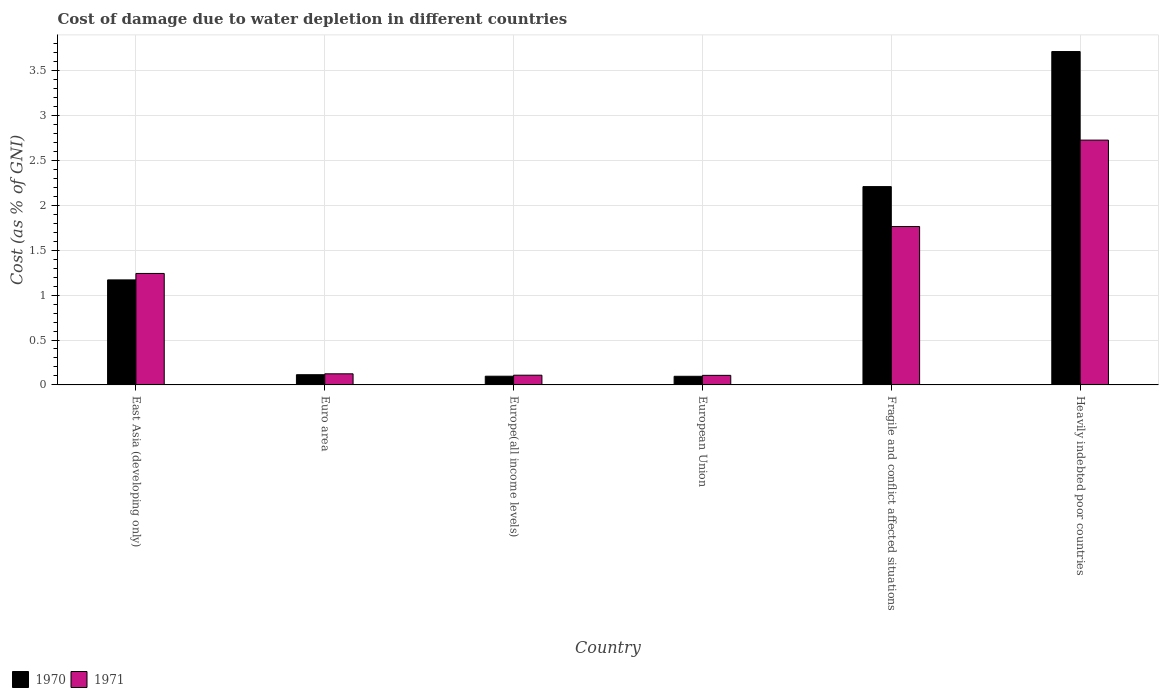Are the number of bars on each tick of the X-axis equal?
Provide a short and direct response. Yes. What is the label of the 3rd group of bars from the left?
Give a very brief answer. Europe(all income levels). What is the cost of damage caused due to water depletion in 1971 in East Asia (developing only)?
Offer a terse response. 1.24. Across all countries, what is the maximum cost of damage caused due to water depletion in 1971?
Offer a very short reply. 2.73. Across all countries, what is the minimum cost of damage caused due to water depletion in 1971?
Your answer should be compact. 0.11. In which country was the cost of damage caused due to water depletion in 1971 maximum?
Offer a terse response. Heavily indebted poor countries. What is the total cost of damage caused due to water depletion in 1970 in the graph?
Ensure brevity in your answer.  7.4. What is the difference between the cost of damage caused due to water depletion in 1970 in East Asia (developing only) and that in Heavily indebted poor countries?
Your answer should be very brief. -2.54. What is the difference between the cost of damage caused due to water depletion in 1970 in Heavily indebted poor countries and the cost of damage caused due to water depletion in 1971 in Euro area?
Offer a very short reply. 3.59. What is the average cost of damage caused due to water depletion in 1970 per country?
Ensure brevity in your answer.  1.23. What is the difference between the cost of damage caused due to water depletion of/in 1970 and cost of damage caused due to water depletion of/in 1971 in Fragile and conflict affected situations?
Make the answer very short. 0.44. In how many countries, is the cost of damage caused due to water depletion in 1971 greater than 1.6 %?
Your answer should be very brief. 2. What is the ratio of the cost of damage caused due to water depletion in 1970 in East Asia (developing only) to that in Euro area?
Ensure brevity in your answer.  10.3. Is the difference between the cost of damage caused due to water depletion in 1970 in Euro area and Heavily indebted poor countries greater than the difference between the cost of damage caused due to water depletion in 1971 in Euro area and Heavily indebted poor countries?
Offer a very short reply. No. What is the difference between the highest and the second highest cost of damage caused due to water depletion in 1970?
Your answer should be very brief. -1.04. What is the difference between the highest and the lowest cost of damage caused due to water depletion in 1971?
Your response must be concise. 2.62. Is the sum of the cost of damage caused due to water depletion in 1971 in Fragile and conflict affected situations and Heavily indebted poor countries greater than the maximum cost of damage caused due to water depletion in 1970 across all countries?
Offer a very short reply. Yes. What does the 1st bar from the left in Heavily indebted poor countries represents?
Your response must be concise. 1970. What does the 2nd bar from the right in Fragile and conflict affected situations represents?
Your answer should be compact. 1970. How many bars are there?
Make the answer very short. 12. Are all the bars in the graph horizontal?
Offer a very short reply. No. How many countries are there in the graph?
Your response must be concise. 6. Are the values on the major ticks of Y-axis written in scientific E-notation?
Offer a very short reply. No. Does the graph contain grids?
Your answer should be very brief. Yes. How many legend labels are there?
Offer a very short reply. 2. How are the legend labels stacked?
Your response must be concise. Horizontal. What is the title of the graph?
Provide a short and direct response. Cost of damage due to water depletion in different countries. Does "1987" appear as one of the legend labels in the graph?
Offer a terse response. No. What is the label or title of the X-axis?
Your response must be concise. Country. What is the label or title of the Y-axis?
Offer a very short reply. Cost (as % of GNI). What is the Cost (as % of GNI) in 1970 in East Asia (developing only)?
Your answer should be compact. 1.17. What is the Cost (as % of GNI) of 1971 in East Asia (developing only)?
Provide a succinct answer. 1.24. What is the Cost (as % of GNI) in 1970 in Euro area?
Ensure brevity in your answer.  0.11. What is the Cost (as % of GNI) of 1971 in Euro area?
Your answer should be compact. 0.12. What is the Cost (as % of GNI) of 1970 in Europe(all income levels)?
Your response must be concise. 0.1. What is the Cost (as % of GNI) of 1971 in Europe(all income levels)?
Offer a terse response. 0.11. What is the Cost (as % of GNI) in 1970 in European Union?
Keep it short and to the point. 0.1. What is the Cost (as % of GNI) of 1971 in European Union?
Ensure brevity in your answer.  0.11. What is the Cost (as % of GNI) in 1970 in Fragile and conflict affected situations?
Offer a very short reply. 2.21. What is the Cost (as % of GNI) of 1971 in Fragile and conflict affected situations?
Offer a terse response. 1.76. What is the Cost (as % of GNI) of 1970 in Heavily indebted poor countries?
Ensure brevity in your answer.  3.71. What is the Cost (as % of GNI) of 1971 in Heavily indebted poor countries?
Provide a short and direct response. 2.73. Across all countries, what is the maximum Cost (as % of GNI) in 1970?
Offer a terse response. 3.71. Across all countries, what is the maximum Cost (as % of GNI) in 1971?
Your answer should be very brief. 2.73. Across all countries, what is the minimum Cost (as % of GNI) of 1970?
Your response must be concise. 0.1. Across all countries, what is the minimum Cost (as % of GNI) of 1971?
Give a very brief answer. 0.11. What is the total Cost (as % of GNI) in 1970 in the graph?
Offer a terse response. 7.4. What is the total Cost (as % of GNI) in 1971 in the graph?
Your answer should be compact. 6.07. What is the difference between the Cost (as % of GNI) of 1970 in East Asia (developing only) and that in Euro area?
Give a very brief answer. 1.06. What is the difference between the Cost (as % of GNI) in 1971 in East Asia (developing only) and that in Euro area?
Your response must be concise. 1.12. What is the difference between the Cost (as % of GNI) of 1970 in East Asia (developing only) and that in Europe(all income levels)?
Ensure brevity in your answer.  1.07. What is the difference between the Cost (as % of GNI) of 1971 in East Asia (developing only) and that in Europe(all income levels)?
Offer a very short reply. 1.13. What is the difference between the Cost (as % of GNI) of 1970 in East Asia (developing only) and that in European Union?
Give a very brief answer. 1.07. What is the difference between the Cost (as % of GNI) of 1971 in East Asia (developing only) and that in European Union?
Keep it short and to the point. 1.13. What is the difference between the Cost (as % of GNI) of 1970 in East Asia (developing only) and that in Fragile and conflict affected situations?
Provide a short and direct response. -1.04. What is the difference between the Cost (as % of GNI) in 1971 in East Asia (developing only) and that in Fragile and conflict affected situations?
Offer a very short reply. -0.52. What is the difference between the Cost (as % of GNI) of 1970 in East Asia (developing only) and that in Heavily indebted poor countries?
Provide a succinct answer. -2.54. What is the difference between the Cost (as % of GNI) in 1971 in East Asia (developing only) and that in Heavily indebted poor countries?
Give a very brief answer. -1.48. What is the difference between the Cost (as % of GNI) of 1970 in Euro area and that in Europe(all income levels)?
Keep it short and to the point. 0.02. What is the difference between the Cost (as % of GNI) in 1971 in Euro area and that in Europe(all income levels)?
Provide a succinct answer. 0.02. What is the difference between the Cost (as % of GNI) in 1970 in Euro area and that in European Union?
Provide a short and direct response. 0.02. What is the difference between the Cost (as % of GNI) in 1971 in Euro area and that in European Union?
Ensure brevity in your answer.  0.02. What is the difference between the Cost (as % of GNI) in 1970 in Euro area and that in Fragile and conflict affected situations?
Ensure brevity in your answer.  -2.09. What is the difference between the Cost (as % of GNI) of 1971 in Euro area and that in Fragile and conflict affected situations?
Offer a terse response. -1.64. What is the difference between the Cost (as % of GNI) in 1970 in Euro area and that in Heavily indebted poor countries?
Keep it short and to the point. -3.6. What is the difference between the Cost (as % of GNI) in 1971 in Euro area and that in Heavily indebted poor countries?
Your answer should be compact. -2.6. What is the difference between the Cost (as % of GNI) of 1970 in Europe(all income levels) and that in European Union?
Ensure brevity in your answer.  0. What is the difference between the Cost (as % of GNI) in 1971 in Europe(all income levels) and that in European Union?
Provide a short and direct response. 0. What is the difference between the Cost (as % of GNI) in 1970 in Europe(all income levels) and that in Fragile and conflict affected situations?
Offer a terse response. -2.11. What is the difference between the Cost (as % of GNI) of 1971 in Europe(all income levels) and that in Fragile and conflict affected situations?
Offer a terse response. -1.66. What is the difference between the Cost (as % of GNI) in 1970 in Europe(all income levels) and that in Heavily indebted poor countries?
Ensure brevity in your answer.  -3.62. What is the difference between the Cost (as % of GNI) in 1971 in Europe(all income levels) and that in Heavily indebted poor countries?
Ensure brevity in your answer.  -2.62. What is the difference between the Cost (as % of GNI) in 1970 in European Union and that in Fragile and conflict affected situations?
Your response must be concise. -2.11. What is the difference between the Cost (as % of GNI) in 1971 in European Union and that in Fragile and conflict affected situations?
Provide a succinct answer. -1.66. What is the difference between the Cost (as % of GNI) of 1970 in European Union and that in Heavily indebted poor countries?
Offer a very short reply. -3.62. What is the difference between the Cost (as % of GNI) in 1971 in European Union and that in Heavily indebted poor countries?
Your answer should be compact. -2.62. What is the difference between the Cost (as % of GNI) in 1970 in Fragile and conflict affected situations and that in Heavily indebted poor countries?
Your response must be concise. -1.5. What is the difference between the Cost (as % of GNI) of 1971 in Fragile and conflict affected situations and that in Heavily indebted poor countries?
Your answer should be very brief. -0.96. What is the difference between the Cost (as % of GNI) of 1970 in East Asia (developing only) and the Cost (as % of GNI) of 1971 in Euro area?
Your answer should be very brief. 1.05. What is the difference between the Cost (as % of GNI) in 1970 in East Asia (developing only) and the Cost (as % of GNI) in 1971 in Europe(all income levels)?
Offer a terse response. 1.06. What is the difference between the Cost (as % of GNI) of 1970 in East Asia (developing only) and the Cost (as % of GNI) of 1971 in European Union?
Provide a short and direct response. 1.06. What is the difference between the Cost (as % of GNI) of 1970 in East Asia (developing only) and the Cost (as % of GNI) of 1971 in Fragile and conflict affected situations?
Ensure brevity in your answer.  -0.59. What is the difference between the Cost (as % of GNI) of 1970 in East Asia (developing only) and the Cost (as % of GNI) of 1971 in Heavily indebted poor countries?
Your answer should be very brief. -1.56. What is the difference between the Cost (as % of GNI) of 1970 in Euro area and the Cost (as % of GNI) of 1971 in Europe(all income levels)?
Provide a succinct answer. 0.01. What is the difference between the Cost (as % of GNI) of 1970 in Euro area and the Cost (as % of GNI) of 1971 in European Union?
Provide a succinct answer. 0.01. What is the difference between the Cost (as % of GNI) of 1970 in Euro area and the Cost (as % of GNI) of 1971 in Fragile and conflict affected situations?
Your response must be concise. -1.65. What is the difference between the Cost (as % of GNI) in 1970 in Euro area and the Cost (as % of GNI) in 1971 in Heavily indebted poor countries?
Provide a short and direct response. -2.61. What is the difference between the Cost (as % of GNI) of 1970 in Europe(all income levels) and the Cost (as % of GNI) of 1971 in European Union?
Offer a terse response. -0.01. What is the difference between the Cost (as % of GNI) in 1970 in Europe(all income levels) and the Cost (as % of GNI) in 1971 in Fragile and conflict affected situations?
Keep it short and to the point. -1.67. What is the difference between the Cost (as % of GNI) in 1970 in Europe(all income levels) and the Cost (as % of GNI) in 1971 in Heavily indebted poor countries?
Provide a short and direct response. -2.63. What is the difference between the Cost (as % of GNI) of 1970 in European Union and the Cost (as % of GNI) of 1971 in Fragile and conflict affected situations?
Your response must be concise. -1.67. What is the difference between the Cost (as % of GNI) in 1970 in European Union and the Cost (as % of GNI) in 1971 in Heavily indebted poor countries?
Ensure brevity in your answer.  -2.63. What is the difference between the Cost (as % of GNI) of 1970 in Fragile and conflict affected situations and the Cost (as % of GNI) of 1971 in Heavily indebted poor countries?
Offer a very short reply. -0.52. What is the average Cost (as % of GNI) in 1970 per country?
Offer a very short reply. 1.23. What is the average Cost (as % of GNI) of 1971 per country?
Give a very brief answer. 1.01. What is the difference between the Cost (as % of GNI) in 1970 and Cost (as % of GNI) in 1971 in East Asia (developing only)?
Provide a succinct answer. -0.07. What is the difference between the Cost (as % of GNI) of 1970 and Cost (as % of GNI) of 1971 in Euro area?
Provide a short and direct response. -0.01. What is the difference between the Cost (as % of GNI) of 1970 and Cost (as % of GNI) of 1971 in Europe(all income levels)?
Offer a terse response. -0.01. What is the difference between the Cost (as % of GNI) in 1970 and Cost (as % of GNI) in 1971 in European Union?
Offer a terse response. -0.01. What is the difference between the Cost (as % of GNI) in 1970 and Cost (as % of GNI) in 1971 in Fragile and conflict affected situations?
Provide a succinct answer. 0.44. What is the difference between the Cost (as % of GNI) in 1970 and Cost (as % of GNI) in 1971 in Heavily indebted poor countries?
Your answer should be compact. 0.99. What is the ratio of the Cost (as % of GNI) of 1970 in East Asia (developing only) to that in Euro area?
Provide a succinct answer. 10.3. What is the ratio of the Cost (as % of GNI) of 1971 in East Asia (developing only) to that in Euro area?
Give a very brief answer. 10.06. What is the ratio of the Cost (as % of GNI) in 1970 in East Asia (developing only) to that in Europe(all income levels)?
Ensure brevity in your answer.  12.06. What is the ratio of the Cost (as % of GNI) of 1971 in East Asia (developing only) to that in Europe(all income levels)?
Offer a very short reply. 11.46. What is the ratio of the Cost (as % of GNI) in 1970 in East Asia (developing only) to that in European Union?
Offer a terse response. 12.18. What is the ratio of the Cost (as % of GNI) in 1971 in East Asia (developing only) to that in European Union?
Your response must be concise. 11.67. What is the ratio of the Cost (as % of GNI) of 1970 in East Asia (developing only) to that in Fragile and conflict affected situations?
Give a very brief answer. 0.53. What is the ratio of the Cost (as % of GNI) of 1971 in East Asia (developing only) to that in Fragile and conflict affected situations?
Your response must be concise. 0.7. What is the ratio of the Cost (as % of GNI) of 1970 in East Asia (developing only) to that in Heavily indebted poor countries?
Offer a very short reply. 0.32. What is the ratio of the Cost (as % of GNI) of 1971 in East Asia (developing only) to that in Heavily indebted poor countries?
Provide a short and direct response. 0.46. What is the ratio of the Cost (as % of GNI) of 1970 in Euro area to that in Europe(all income levels)?
Your answer should be very brief. 1.17. What is the ratio of the Cost (as % of GNI) of 1971 in Euro area to that in Europe(all income levels)?
Your answer should be very brief. 1.14. What is the ratio of the Cost (as % of GNI) in 1970 in Euro area to that in European Union?
Your answer should be compact. 1.18. What is the ratio of the Cost (as % of GNI) of 1971 in Euro area to that in European Union?
Your response must be concise. 1.16. What is the ratio of the Cost (as % of GNI) of 1970 in Euro area to that in Fragile and conflict affected situations?
Your answer should be very brief. 0.05. What is the ratio of the Cost (as % of GNI) of 1971 in Euro area to that in Fragile and conflict affected situations?
Your response must be concise. 0.07. What is the ratio of the Cost (as % of GNI) of 1970 in Euro area to that in Heavily indebted poor countries?
Keep it short and to the point. 0.03. What is the ratio of the Cost (as % of GNI) of 1971 in Euro area to that in Heavily indebted poor countries?
Your answer should be very brief. 0.05. What is the ratio of the Cost (as % of GNI) in 1970 in Europe(all income levels) to that in European Union?
Your answer should be very brief. 1.01. What is the ratio of the Cost (as % of GNI) of 1971 in Europe(all income levels) to that in European Union?
Your answer should be very brief. 1.02. What is the ratio of the Cost (as % of GNI) in 1970 in Europe(all income levels) to that in Fragile and conflict affected situations?
Make the answer very short. 0.04. What is the ratio of the Cost (as % of GNI) of 1971 in Europe(all income levels) to that in Fragile and conflict affected situations?
Your answer should be very brief. 0.06. What is the ratio of the Cost (as % of GNI) in 1970 in Europe(all income levels) to that in Heavily indebted poor countries?
Give a very brief answer. 0.03. What is the ratio of the Cost (as % of GNI) of 1971 in Europe(all income levels) to that in Heavily indebted poor countries?
Offer a terse response. 0.04. What is the ratio of the Cost (as % of GNI) of 1970 in European Union to that in Fragile and conflict affected situations?
Ensure brevity in your answer.  0.04. What is the ratio of the Cost (as % of GNI) in 1971 in European Union to that in Fragile and conflict affected situations?
Give a very brief answer. 0.06. What is the ratio of the Cost (as % of GNI) in 1970 in European Union to that in Heavily indebted poor countries?
Provide a short and direct response. 0.03. What is the ratio of the Cost (as % of GNI) of 1971 in European Union to that in Heavily indebted poor countries?
Make the answer very short. 0.04. What is the ratio of the Cost (as % of GNI) of 1970 in Fragile and conflict affected situations to that in Heavily indebted poor countries?
Offer a very short reply. 0.59. What is the ratio of the Cost (as % of GNI) of 1971 in Fragile and conflict affected situations to that in Heavily indebted poor countries?
Your answer should be compact. 0.65. What is the difference between the highest and the second highest Cost (as % of GNI) in 1970?
Offer a very short reply. 1.5. What is the difference between the highest and the second highest Cost (as % of GNI) in 1971?
Give a very brief answer. 0.96. What is the difference between the highest and the lowest Cost (as % of GNI) in 1970?
Your answer should be compact. 3.62. What is the difference between the highest and the lowest Cost (as % of GNI) in 1971?
Keep it short and to the point. 2.62. 